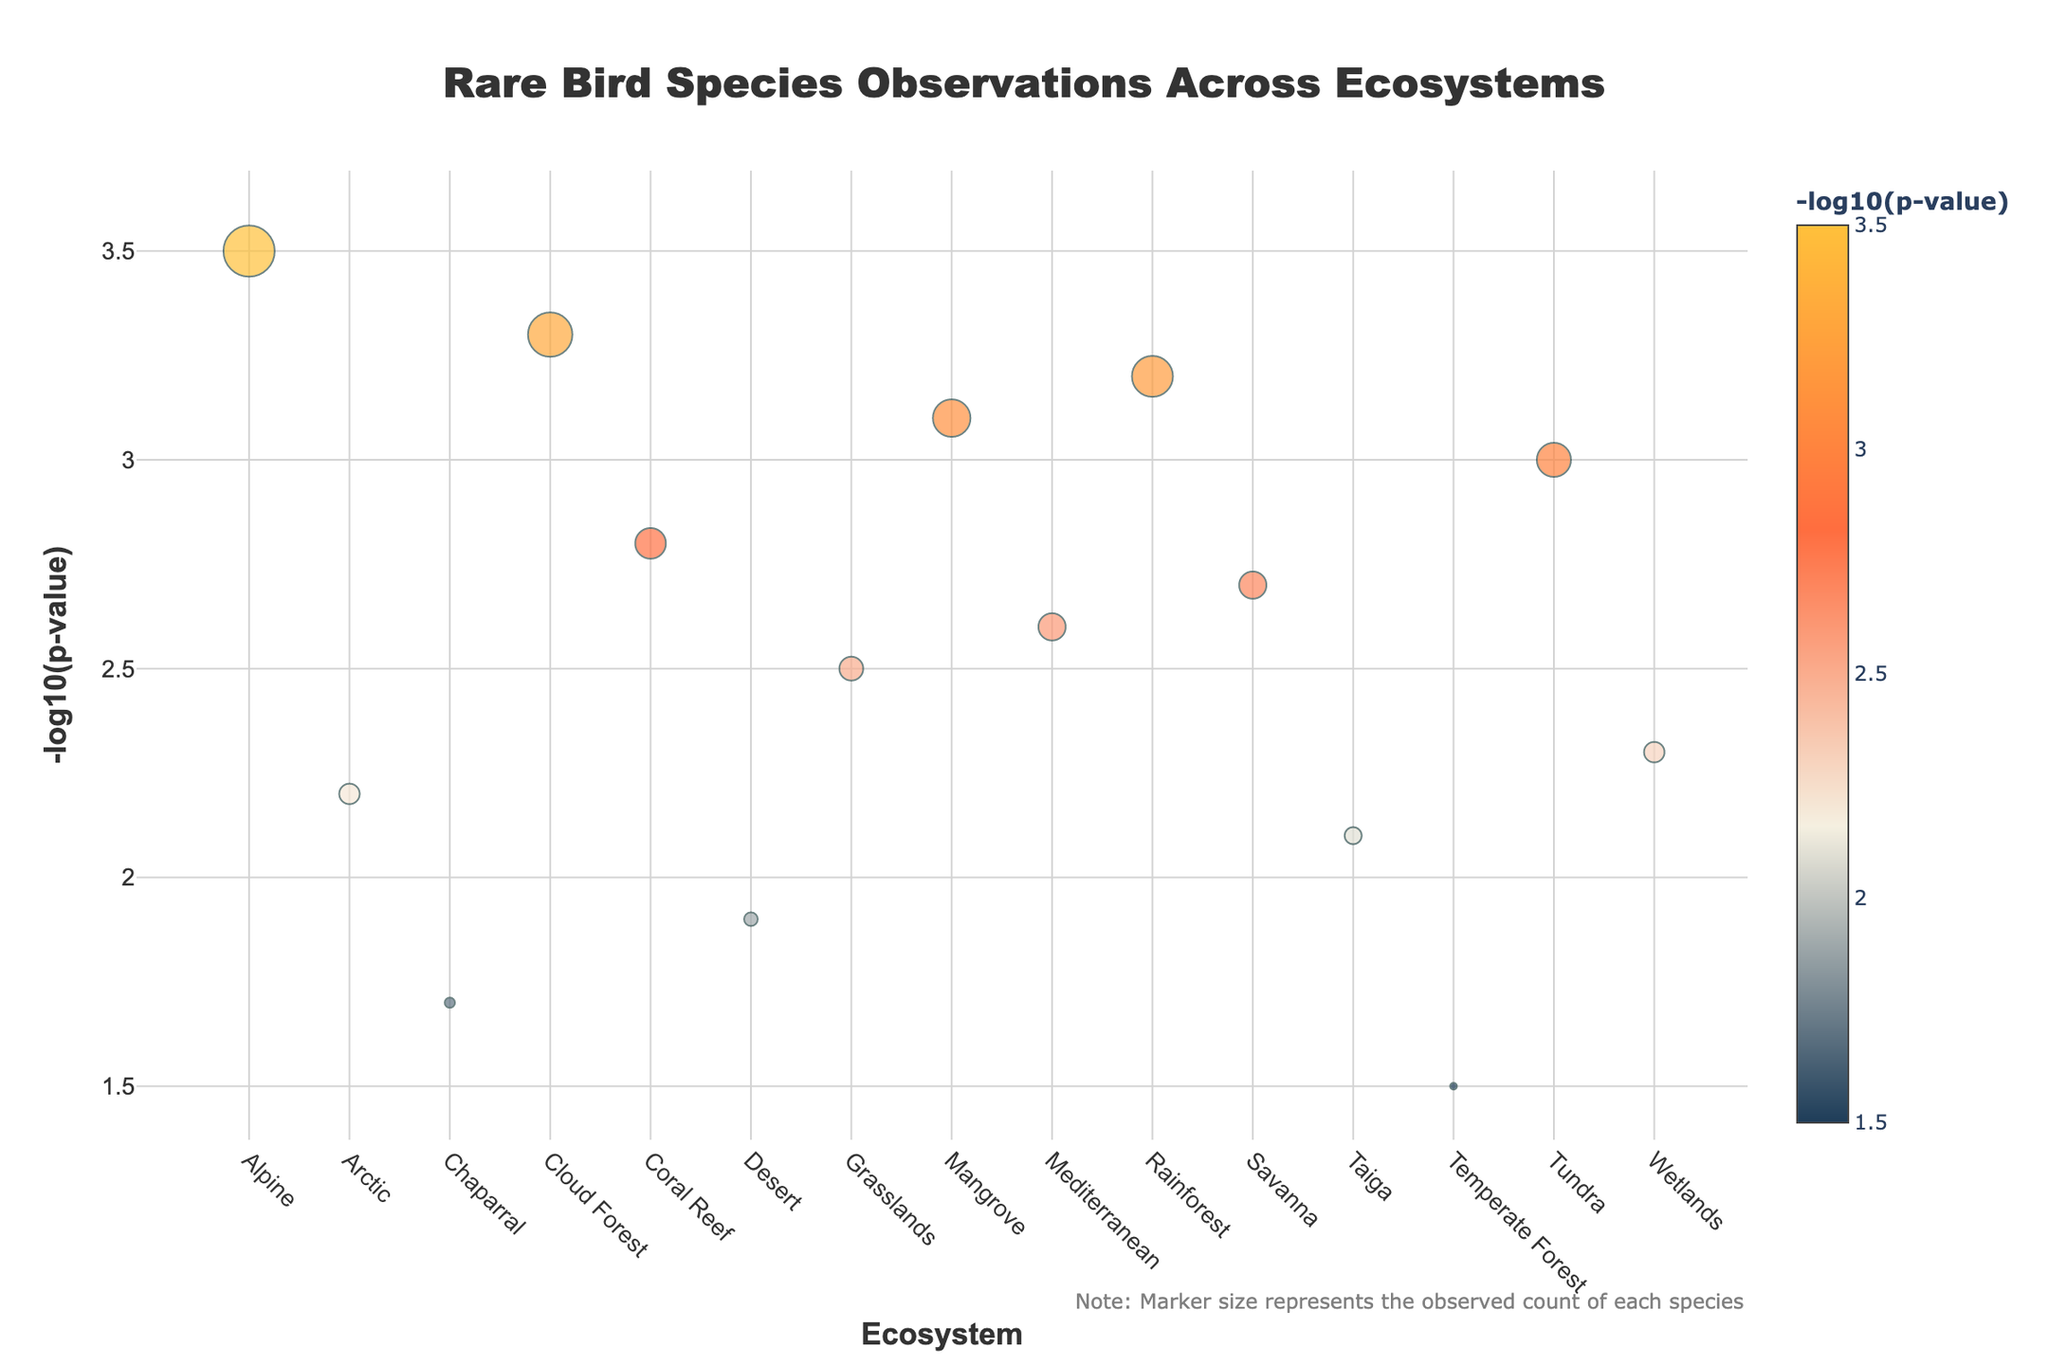What's the title of the plot? The title of the plot is located at the top center of the figure. It is typically in a larger and bold font to distinguish it from other text.
Answer: Rare Bird Species Observations Across Ecosystems Which ecosystem has the highest -log10(p-value)? By observing the y-axis and identifying the highest point on the plot, we see that the Golden Eagle in the Alpine ecosystem has the highest value.
Answer: Alpine How many ecosystems have a -log10(p-value) greater than 3? To determine this, count the data points that are above the y value of 3 on the y-axis. Observing the plot shows that there are four such points: Rainforest, Alpine, Tundra, and Cloud Forest.
Answer: 4 What is the observed count for the species with the lowest -log10(p-value)? The species with the lowest -log10(p-value) is the Ivory-billed Woodpecker in the Temperate Forest, visible as the lowest point in the plot. The size of the marker can be correlated with the observed count, which here is 2.
Answer: 2 Compare the observed counts of Harpy Eagle and Spectacled Eider. Which is larger? By locating the respective markers for Harpy Eagle (Rainforest) and Spectacled Eider (Arctic), we observe that the Harpy Eagle has a larger observed count compared to the Spectacled Eider. This can be seen from the marker size, which represents the observed count.
Answer: Harpy Eagle What ecosystem has the species with the fourth highest -log10(p-value)? By ordering the markers from highest to lowest -log10(p-value), the fourth point down corresponds to the one in the Mangrove ecosystem for the Roseate Spoonbill.
Answer: Mangrove Which species in the Wetlands ecosystem is observed, and what is its -log10(p-value)? Locate the Wetlands on the x-axis, and observe the vertical position of the marker that represents the Whooping Crane. The -log10(p-value) for this species is given, and it is 2.3.
Answer: Whooping Crane, 2.3 What is the difference in observed counts between the Ivory-billed Woodpecker and the California Condor? Subtract the observed count of the smaller marker from the larger one. Here, the Ivory-billed Woodpecker has 2, and the California Condor has 4, giving a difference of 2.
Answer: 2 Are there any ecosystems where multiple species have been observed? Each marker on the plot corresponds to a distinct ecosystem-species pair without overlapping points, so all ecosystems have only one species observed.
Answer: No Which species in the Coral Reef has been recorded, and what is the observed count? Locate the Coral Reef on the x-axis and observe the marker there. The species recorded is the Red-footed Booby, with an observed count of 9.
Answer: Red-footed Booby, 9 